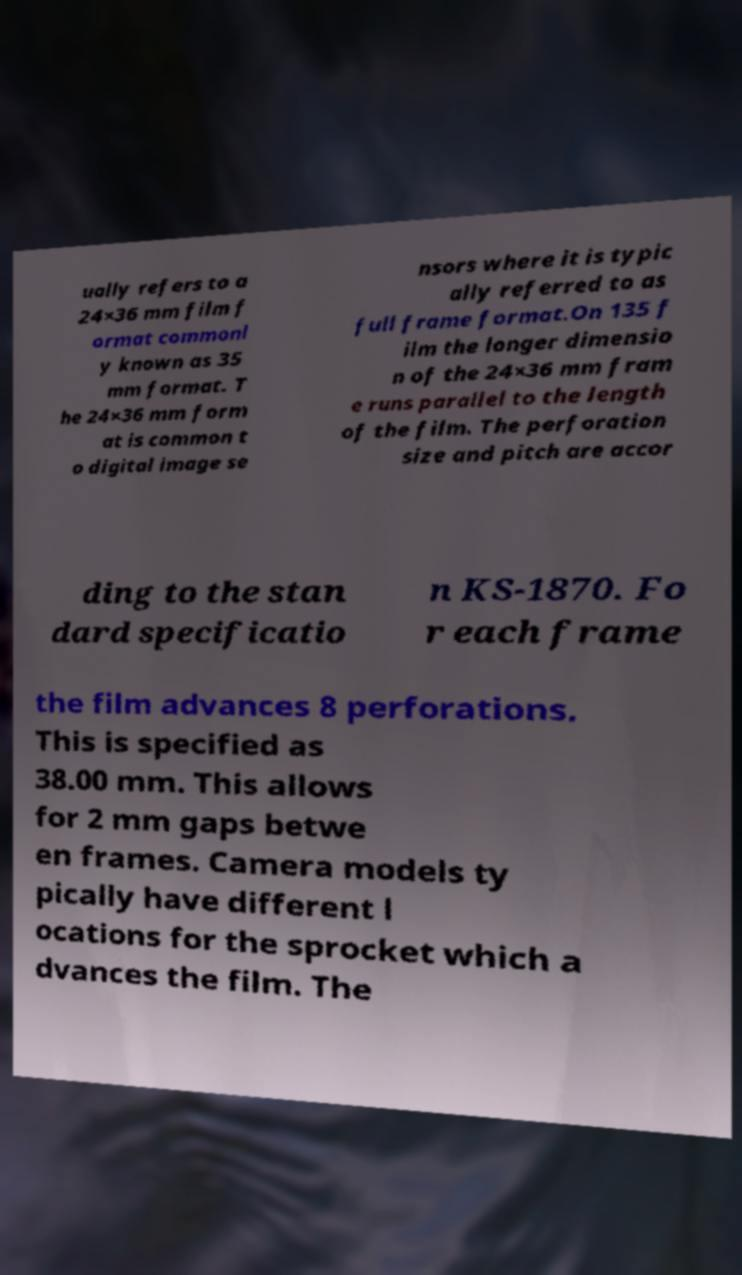Could you assist in decoding the text presented in this image and type it out clearly? ually refers to a 24×36 mm film f ormat commonl y known as 35 mm format. T he 24×36 mm form at is common t o digital image se nsors where it is typic ally referred to as full frame format.On 135 f ilm the longer dimensio n of the 24×36 mm fram e runs parallel to the length of the film. The perforation size and pitch are accor ding to the stan dard specificatio n KS-1870. Fo r each frame the film advances 8 perforations. This is specified as 38.00 mm. This allows for 2 mm gaps betwe en frames. Camera models ty pically have different l ocations for the sprocket which a dvances the film. The 